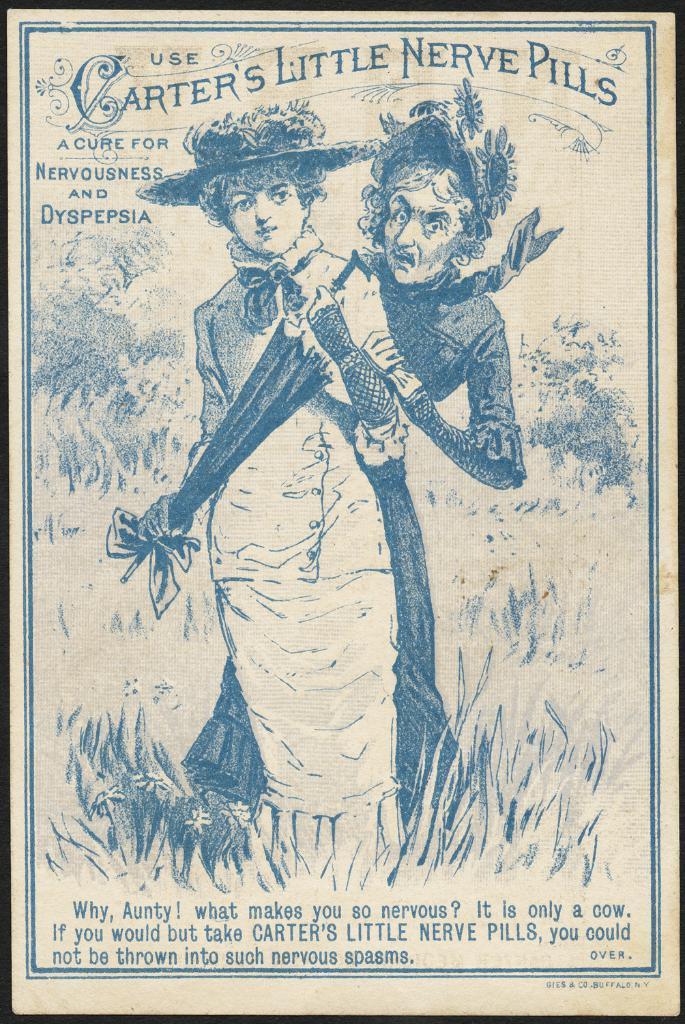Describe this image in one or two sentences. In this image we can see the picture of two people and some text on it. 